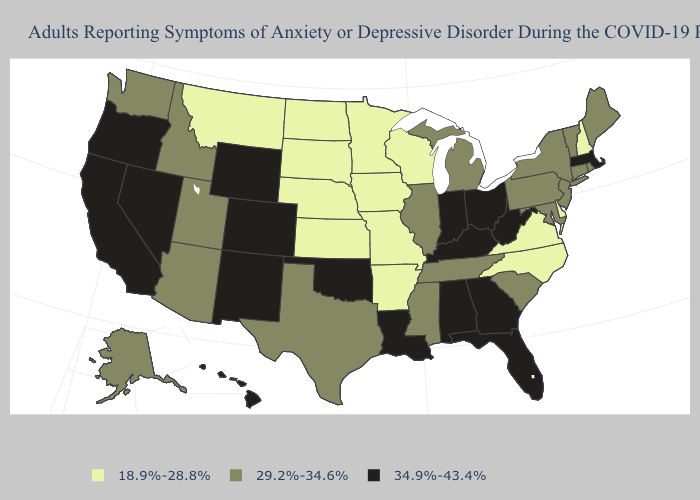What is the lowest value in states that border Wisconsin?
Concise answer only. 18.9%-28.8%. Name the states that have a value in the range 29.2%-34.6%?
Answer briefly. Alaska, Arizona, Connecticut, Idaho, Illinois, Maine, Maryland, Michigan, Mississippi, New Jersey, New York, Pennsylvania, Rhode Island, South Carolina, Tennessee, Texas, Utah, Vermont, Washington. Which states hav the highest value in the Northeast?
Concise answer only. Massachusetts. Name the states that have a value in the range 29.2%-34.6%?
Answer briefly. Alaska, Arizona, Connecticut, Idaho, Illinois, Maine, Maryland, Michigan, Mississippi, New Jersey, New York, Pennsylvania, Rhode Island, South Carolina, Tennessee, Texas, Utah, Vermont, Washington. What is the value of Missouri?
Short answer required. 18.9%-28.8%. Does Oklahoma have the same value as Nebraska?
Be succinct. No. What is the value of Utah?
Keep it brief. 29.2%-34.6%. How many symbols are there in the legend?
Concise answer only. 3. What is the highest value in the USA?
Give a very brief answer. 34.9%-43.4%. Does Iowa have the lowest value in the USA?
Write a very short answer. Yes. Does Mississippi have the lowest value in the South?
Concise answer only. No. What is the lowest value in the Northeast?
Answer briefly. 18.9%-28.8%. Does Nebraska have the lowest value in the USA?
Answer briefly. Yes. What is the value of Delaware?
Short answer required. 18.9%-28.8%. Name the states that have a value in the range 18.9%-28.8%?
Give a very brief answer. Arkansas, Delaware, Iowa, Kansas, Minnesota, Missouri, Montana, Nebraska, New Hampshire, North Carolina, North Dakota, South Dakota, Virginia, Wisconsin. 